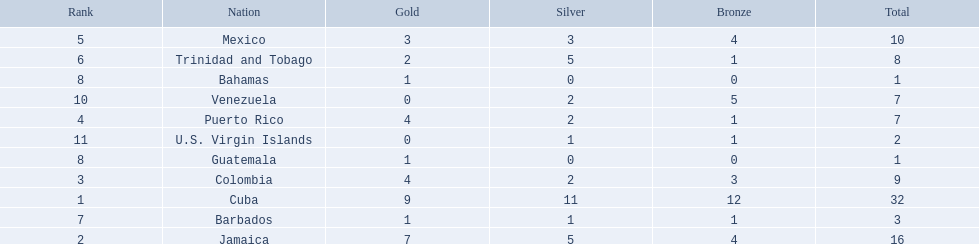What nation has won at least 4 gold medals? Cuba, Jamaica, Colombia, Puerto Rico. Of these countries who has won the least amount of bronze medals? Puerto Rico. 